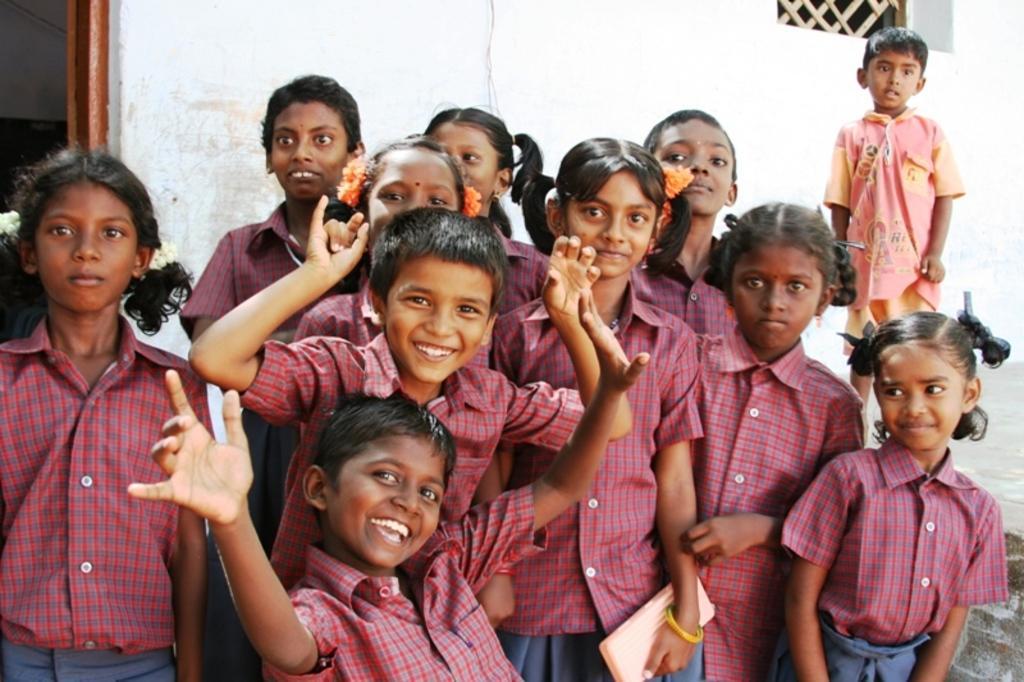Describe this image in one or two sentences. Here I can see few children wearing uniforms, smiling and giving pose for the picture. In the background there is wall and a window. 